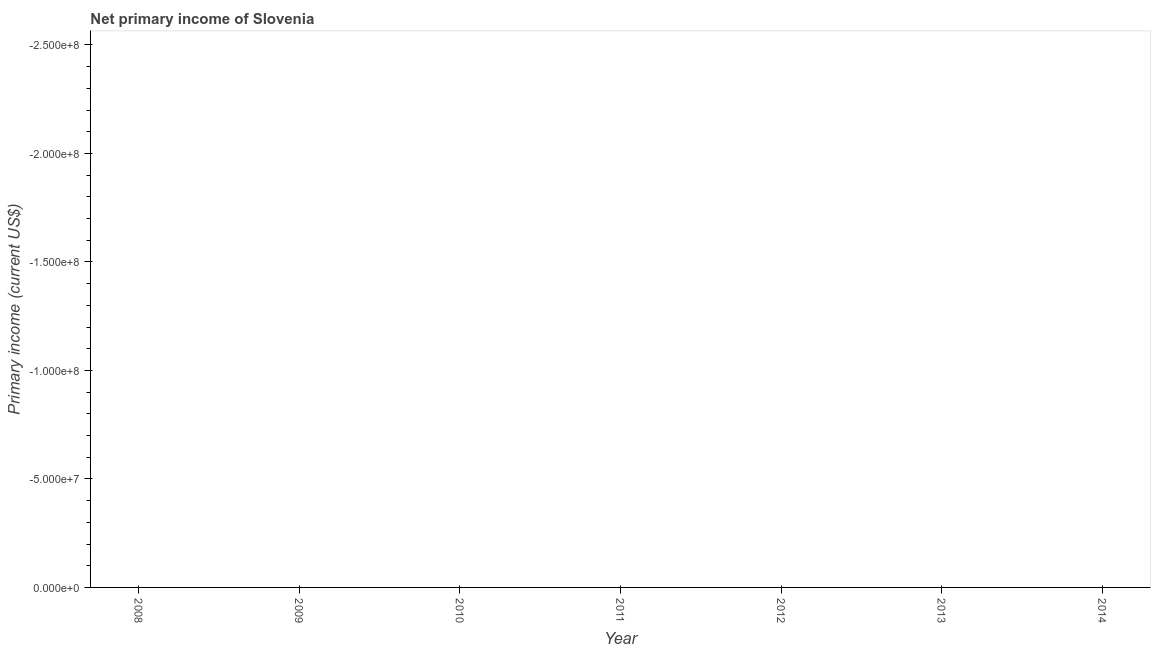What is the amount of primary income in 2014?
Keep it short and to the point. 0. What is the average amount of primary income per year?
Your answer should be very brief. 0. In how many years, is the amount of primary income greater than -30000000 US$?
Ensure brevity in your answer.  0. In how many years, is the amount of primary income greater than the average amount of primary income taken over all years?
Keep it short and to the point. 0. How many dotlines are there?
Give a very brief answer. 0. How many years are there in the graph?
Keep it short and to the point. 7. Are the values on the major ticks of Y-axis written in scientific E-notation?
Make the answer very short. Yes. Does the graph contain any zero values?
Give a very brief answer. Yes. What is the title of the graph?
Keep it short and to the point. Net primary income of Slovenia. What is the label or title of the X-axis?
Provide a short and direct response. Year. What is the label or title of the Y-axis?
Make the answer very short. Primary income (current US$). What is the Primary income (current US$) in 2008?
Offer a very short reply. 0. What is the Primary income (current US$) in 2010?
Your response must be concise. 0. What is the Primary income (current US$) in 2011?
Provide a succinct answer. 0. What is the Primary income (current US$) in 2012?
Provide a succinct answer. 0. 